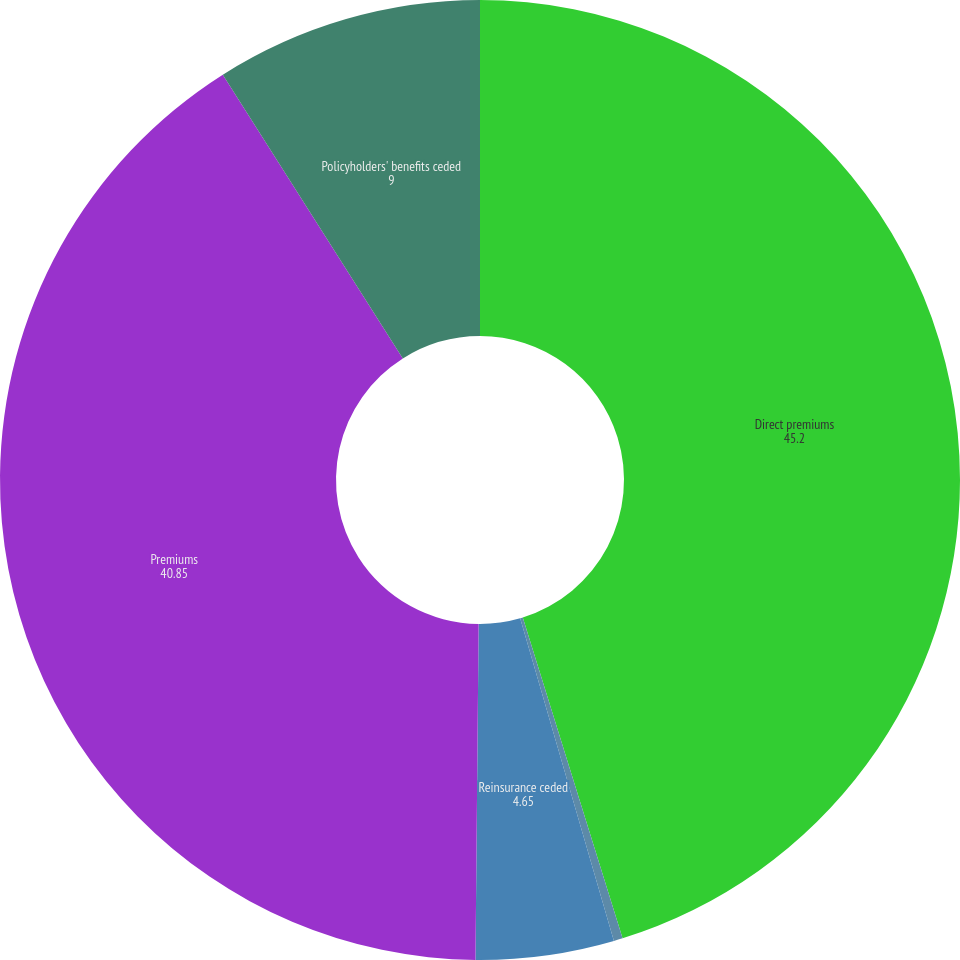<chart> <loc_0><loc_0><loc_500><loc_500><pie_chart><fcel>Direct premiums<fcel>Reinsurance assumed<fcel>Reinsurance ceded<fcel>Premiums<fcel>Policyholders' benefits ceded<nl><fcel>45.2%<fcel>0.3%<fcel>4.65%<fcel>40.85%<fcel>9.0%<nl></chart> 